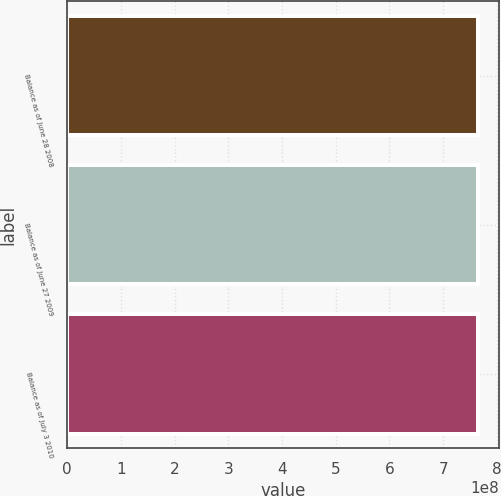Convert chart to OTSL. <chart><loc_0><loc_0><loc_500><loc_500><bar_chart><fcel>Balance as of June 28 2008<fcel>Balance as of June 27 2009<fcel>Balance as of July 3 2010<nl><fcel>7.65175e+08<fcel>7.65175e+08<fcel>7.65175e+08<nl></chart> 